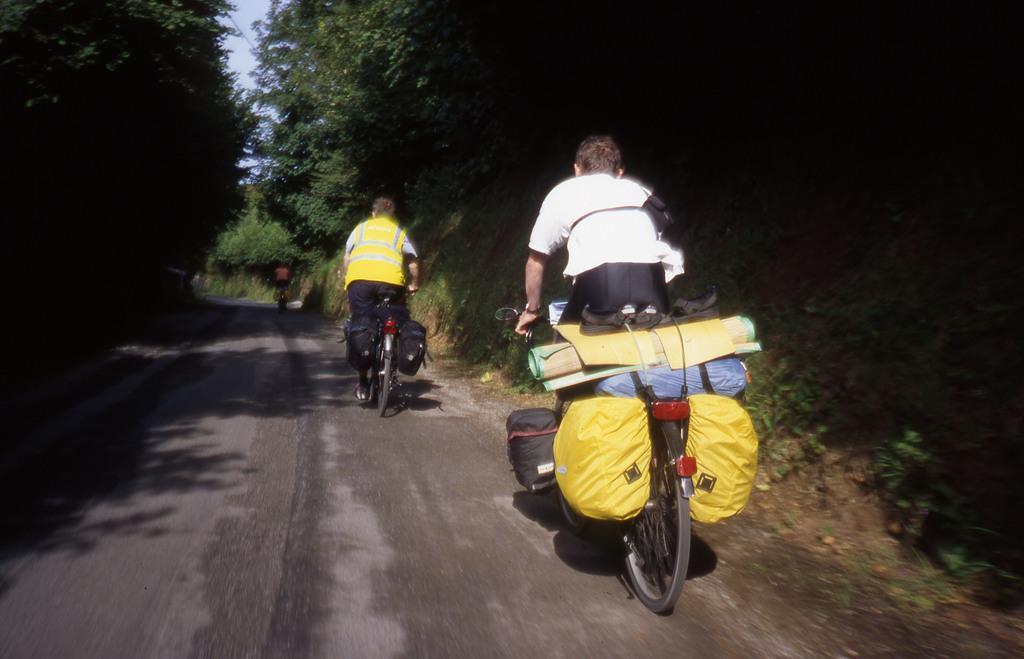Describe this image in one or two sentences. In this picture there are two men who are riding a bicycle. There is a bag, sheet on a bicycle. There is also another person who is riding a bicycle on the road. There are trees on both sides of the road. 